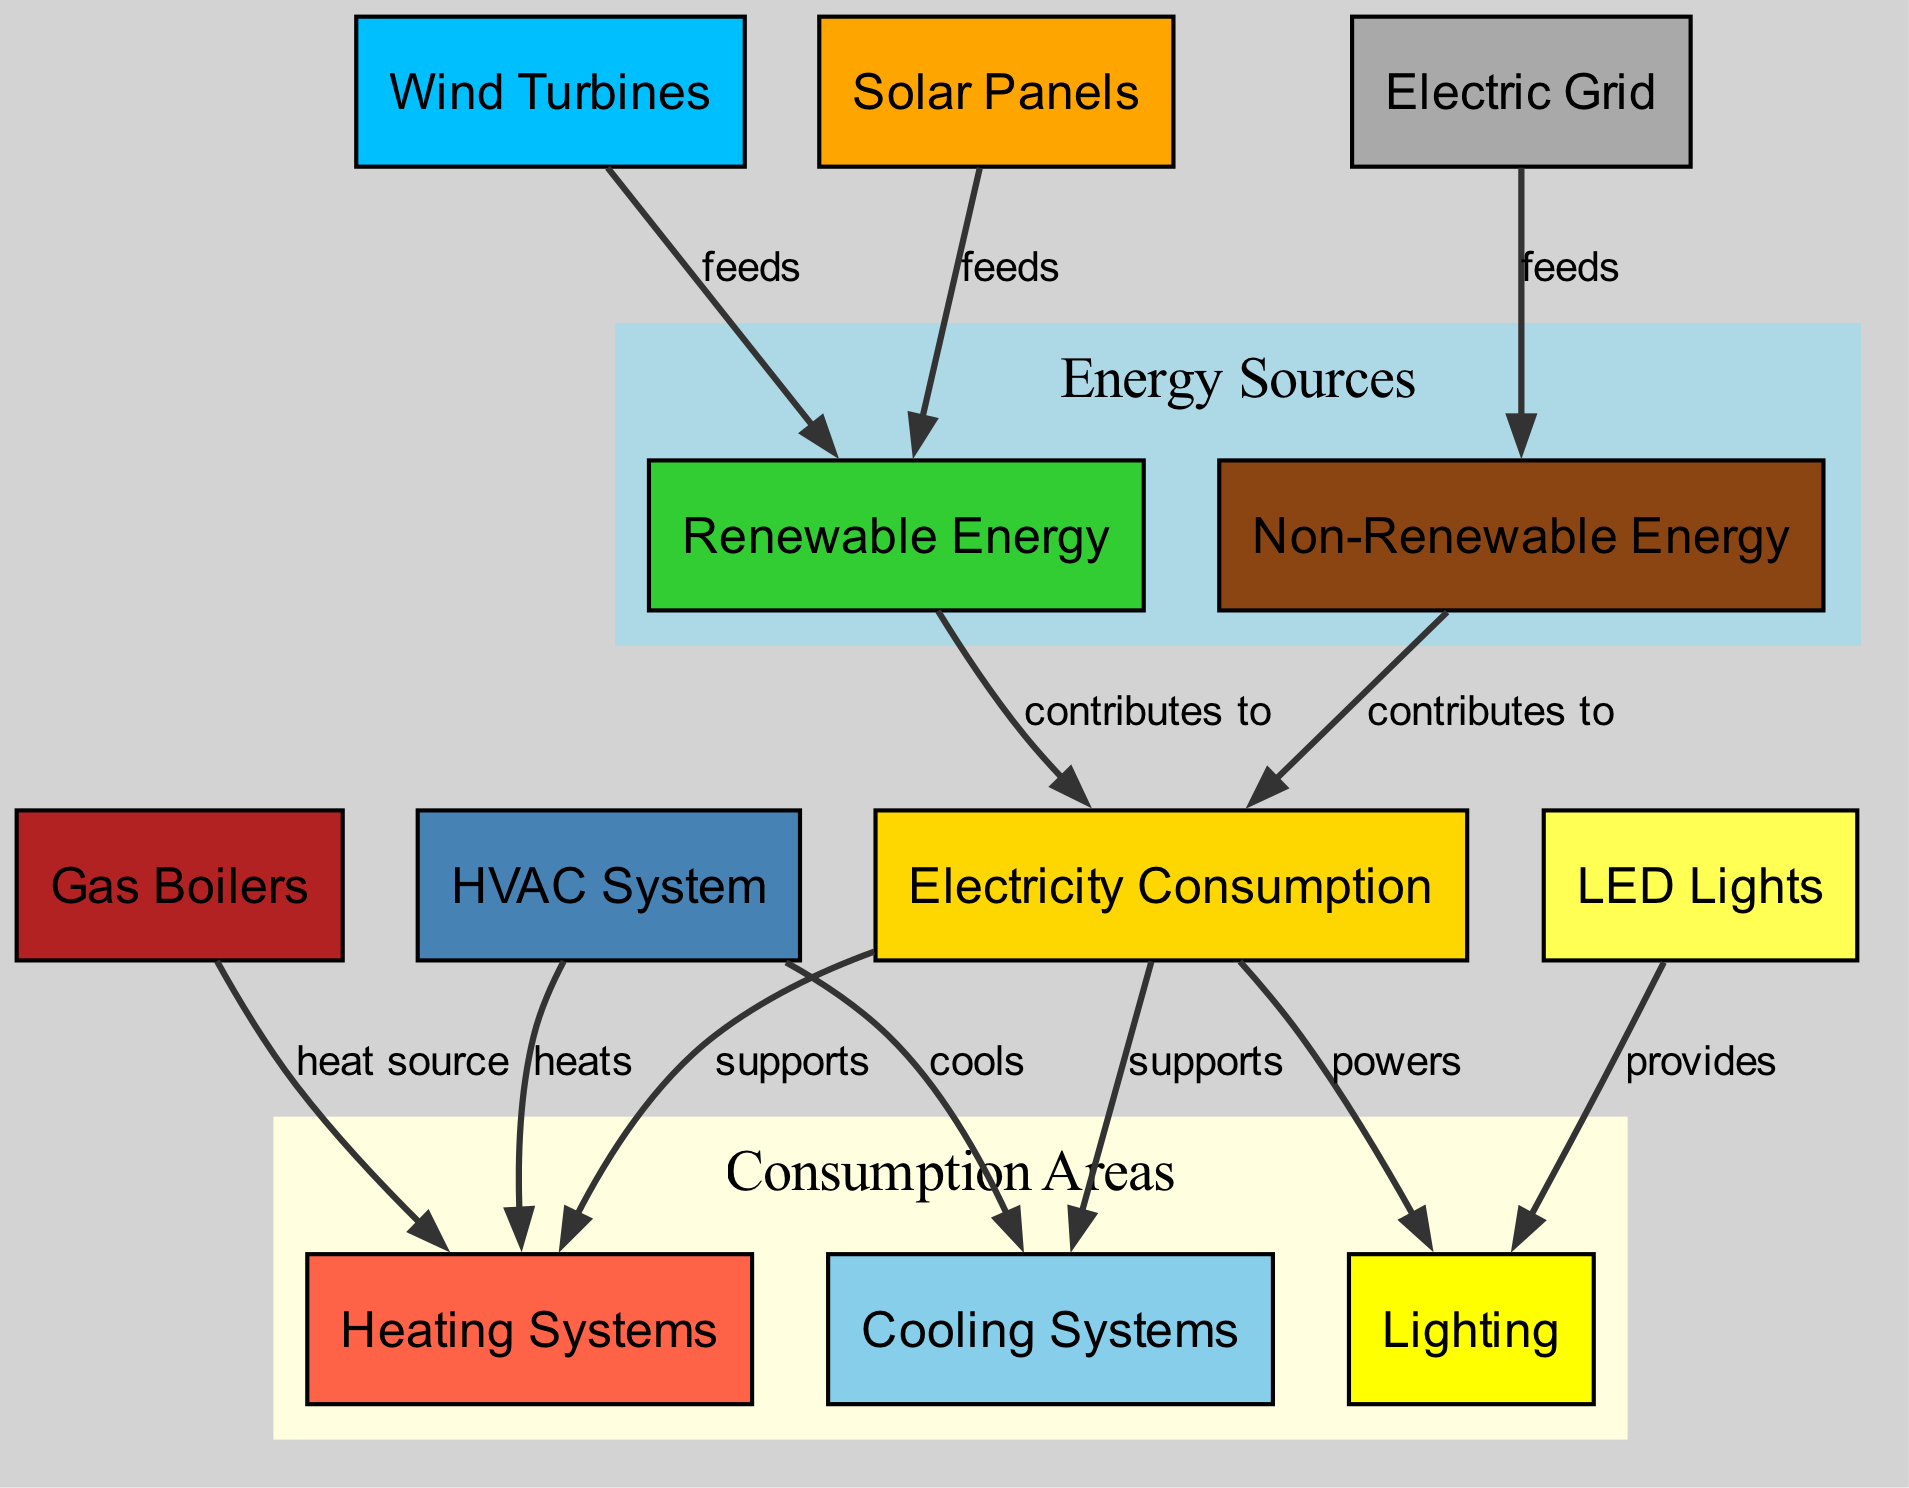What are the two types of energy sources shown in the diagram? The diagram identifies two categories of energy sources: Renewable Energy and Non-Renewable Energy, labeled distinctly within the nodes.
Answer: Renewable Energy, Non-Renewable Energy Which node powers the Lighting? The edge connecting Electricity Consumption to Lighting indicates that Electricity Consumption powers the Lighting system in the building.
Answer: Electricity Consumption How many nodes are present in the diagram? By counting all unique elements defined in the nodes section, there are twelve nodes available in total within the diagram.
Answer: Twelve What contributes to Electricity Consumption? Both Renewable Energy and Non-Renewable Energy nodes are linked by edges that specify they contribute to Electricity Consumption, indicating their roles in providing power.
Answer: Renewable Energy, Non-Renewable Energy Which system is heated by Gas Boilers? The edge from Gas Boilers to Heating Systems clearly states that Gas Boilers serve as a heat source for the Heating Systems within the department building.
Answer: Heating Systems What is used to provide Lighting? LED Lights are directly connected to Lighting in the diagram, where the edge states that LED Lights provide the necessary lighting in the building.
Answer: LED Lights If Electric Grid feeds Non-Renewable Energy, what is the relationship with Renewable Energy? The diagram depicts both Renewable Energy and Non-Renewable Energy contributing to Electricity Consumption, suggesting that while one source is from the Electric Grid, the Renewable sources are independent from it.
Answer: Independent How does the HVAC System interact with Heating and Cooling Systems? The HVAC System has distinct edges leading to Heating Systems, which it heats, and to Cooling Systems, which it cools, indicating its dual role in regulating temperature.
Answer: Heats, Cools What do Solar Panels and Wind Turbines feed into? Solar Panels and Wind Turbines are connected to the Renewable Energy node, indicating that they feed energy into the broader renewable category.
Answer: Renewable Energy 